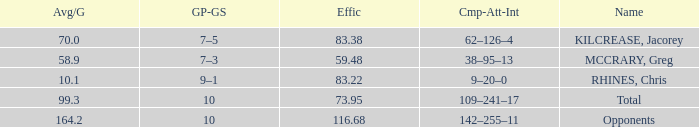What is the total avg/g of McCrary, Greg? 1.0. Write the full table. {'header': ['Avg/G', 'GP-GS', 'Effic', 'Cmp-Att-Int', 'Name'], 'rows': [['70.0', '7–5', '83.38', '62–126–4', 'KILCREASE, Jacorey'], ['58.9', '7–3', '59.48', '38–95–13', 'MCCRARY, Greg'], ['10.1', '9–1', '83.22', '9–20–0', 'RHINES, Chris'], ['99.3', '10', '73.95', '109–241–17', 'Total'], ['164.2', '10', '116.68', '142–255–11', 'Opponents']]} 